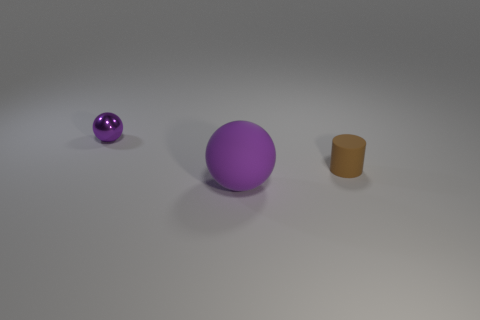Add 1 brown cylinders. How many objects exist? 4 Subtract all cylinders. How many objects are left? 2 Subtract all tiny purple spheres. Subtract all tiny brown rubber cylinders. How many objects are left? 1 Add 3 purple objects. How many purple objects are left? 5 Add 2 large purple rubber objects. How many large purple rubber objects exist? 3 Subtract 0 green spheres. How many objects are left? 3 